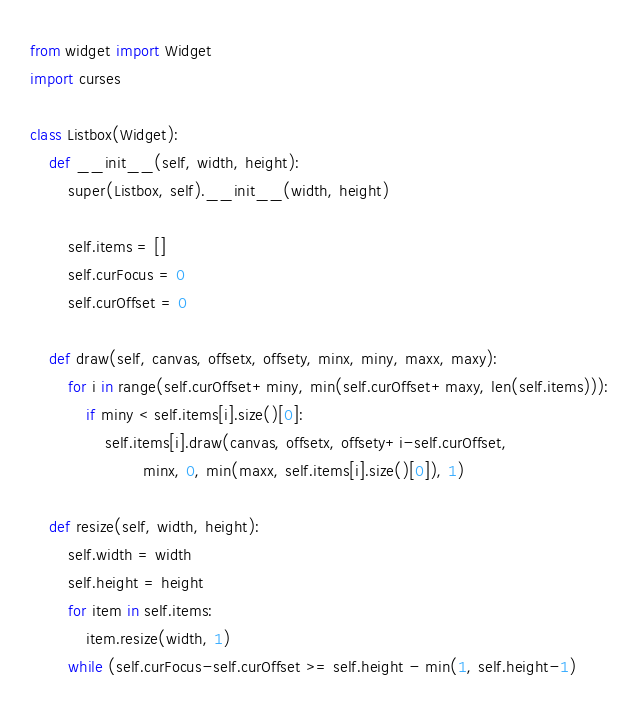<code> <loc_0><loc_0><loc_500><loc_500><_Python_>from widget import Widget
import curses

class Listbox(Widget):
    def __init__(self, width, height):
        super(Listbox, self).__init__(width, height)

        self.items = []
        self.curFocus = 0
        self.curOffset = 0

    def draw(self, canvas, offsetx, offsety, minx, miny, maxx, maxy):
        for i in range(self.curOffset+miny, min(self.curOffset+maxy, len(self.items))):
            if miny < self.items[i].size()[0]:
                self.items[i].draw(canvas, offsetx, offsety+i-self.curOffset,
                        minx, 0, min(maxx, self.items[i].size()[0]), 1)

    def resize(self, width, height):
        self.width = width
        self.height = height
        for item in self.items:
            item.resize(width, 1)
        while (self.curFocus-self.curOffset >= self.height - min(1, self.height-1)</code> 